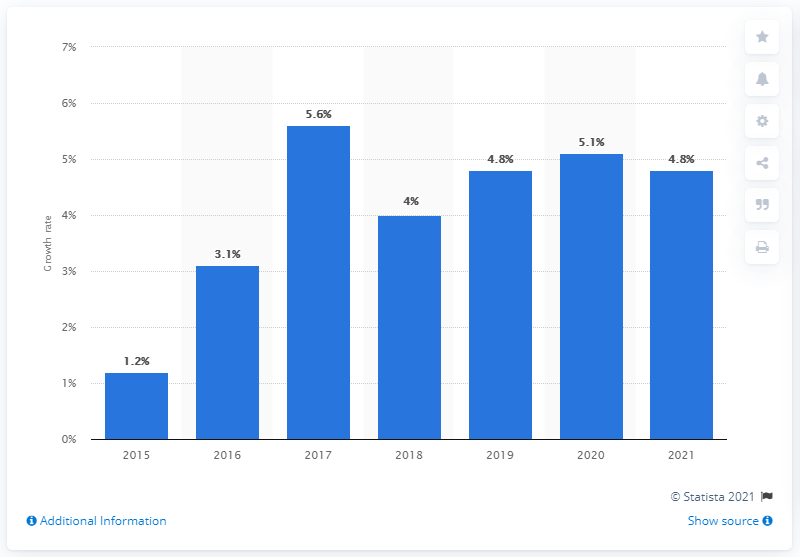Outline some significant characteristics in this image. The global container market is projected to increase by 4.8% between 2020 and 2021. In 2017, the growth rate was the highest among all years. The difference between the highest and lowest growth rates recorded is 4.4%. 